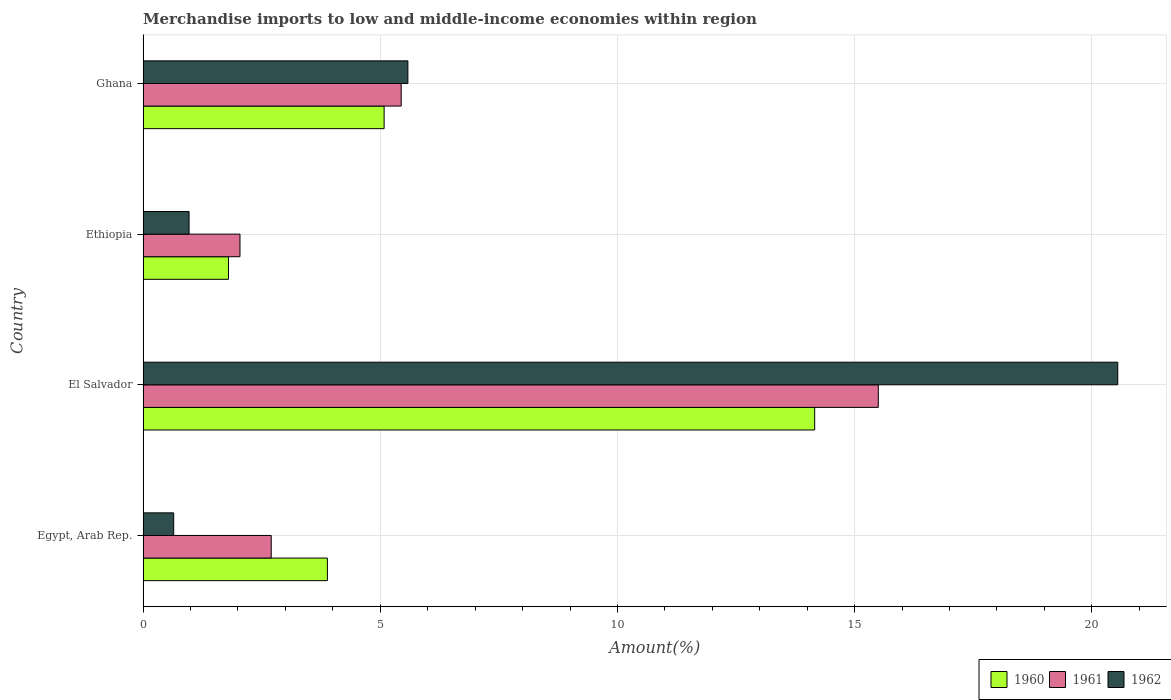How many groups of bars are there?
Offer a very short reply. 4. Are the number of bars per tick equal to the number of legend labels?
Your answer should be very brief. Yes. Are the number of bars on each tick of the Y-axis equal?
Your response must be concise. Yes. How many bars are there on the 4th tick from the top?
Your response must be concise. 3. In how many cases, is the number of bars for a given country not equal to the number of legend labels?
Provide a short and direct response. 0. What is the percentage of amount earned from merchandise imports in 1961 in Ghana?
Make the answer very short. 5.44. Across all countries, what is the maximum percentage of amount earned from merchandise imports in 1962?
Make the answer very short. 20.55. Across all countries, what is the minimum percentage of amount earned from merchandise imports in 1961?
Offer a terse response. 2.04. In which country was the percentage of amount earned from merchandise imports in 1960 maximum?
Your answer should be compact. El Salvador. In which country was the percentage of amount earned from merchandise imports in 1961 minimum?
Keep it short and to the point. Ethiopia. What is the total percentage of amount earned from merchandise imports in 1961 in the graph?
Ensure brevity in your answer.  25.68. What is the difference between the percentage of amount earned from merchandise imports in 1962 in Ethiopia and that in Ghana?
Provide a succinct answer. -4.61. What is the difference between the percentage of amount earned from merchandise imports in 1961 in Ghana and the percentage of amount earned from merchandise imports in 1960 in Egypt, Arab Rep.?
Offer a very short reply. 1.56. What is the average percentage of amount earned from merchandise imports in 1961 per country?
Give a very brief answer. 6.42. What is the difference between the percentage of amount earned from merchandise imports in 1962 and percentage of amount earned from merchandise imports in 1961 in Egypt, Arab Rep.?
Provide a short and direct response. -2.06. In how many countries, is the percentage of amount earned from merchandise imports in 1960 greater than 3 %?
Provide a short and direct response. 3. What is the ratio of the percentage of amount earned from merchandise imports in 1960 in El Salvador to that in Ethiopia?
Provide a short and direct response. 7.86. What is the difference between the highest and the second highest percentage of amount earned from merchandise imports in 1961?
Your answer should be very brief. 10.06. What is the difference between the highest and the lowest percentage of amount earned from merchandise imports in 1961?
Your response must be concise. 13.46. In how many countries, is the percentage of amount earned from merchandise imports in 1962 greater than the average percentage of amount earned from merchandise imports in 1962 taken over all countries?
Provide a short and direct response. 1. Is the sum of the percentage of amount earned from merchandise imports in 1962 in Egypt, Arab Rep. and Ghana greater than the maximum percentage of amount earned from merchandise imports in 1961 across all countries?
Your answer should be very brief. No. What does the 2nd bar from the top in El Salvador represents?
Keep it short and to the point. 1961. What does the 1st bar from the bottom in Ethiopia represents?
Make the answer very short. 1960. Is it the case that in every country, the sum of the percentage of amount earned from merchandise imports in 1960 and percentage of amount earned from merchandise imports in 1961 is greater than the percentage of amount earned from merchandise imports in 1962?
Offer a terse response. Yes. Are the values on the major ticks of X-axis written in scientific E-notation?
Provide a short and direct response. No. Does the graph contain any zero values?
Ensure brevity in your answer.  No. How are the legend labels stacked?
Ensure brevity in your answer.  Horizontal. What is the title of the graph?
Your response must be concise. Merchandise imports to low and middle-income economies within region. What is the label or title of the X-axis?
Give a very brief answer. Amount(%). What is the Amount(%) of 1960 in Egypt, Arab Rep.?
Give a very brief answer. 3.89. What is the Amount(%) of 1961 in Egypt, Arab Rep.?
Your response must be concise. 2.7. What is the Amount(%) in 1962 in Egypt, Arab Rep.?
Make the answer very short. 0.65. What is the Amount(%) of 1960 in El Salvador?
Keep it short and to the point. 14.16. What is the Amount(%) in 1961 in El Salvador?
Make the answer very short. 15.5. What is the Amount(%) of 1962 in El Salvador?
Keep it short and to the point. 20.55. What is the Amount(%) of 1960 in Ethiopia?
Keep it short and to the point. 1.8. What is the Amount(%) of 1961 in Ethiopia?
Give a very brief answer. 2.04. What is the Amount(%) of 1962 in Ethiopia?
Offer a terse response. 0.97. What is the Amount(%) in 1960 in Ghana?
Provide a succinct answer. 5.08. What is the Amount(%) in 1961 in Ghana?
Your answer should be very brief. 5.44. What is the Amount(%) of 1962 in Ghana?
Offer a terse response. 5.58. Across all countries, what is the maximum Amount(%) of 1960?
Give a very brief answer. 14.16. Across all countries, what is the maximum Amount(%) in 1961?
Offer a terse response. 15.5. Across all countries, what is the maximum Amount(%) in 1962?
Provide a succinct answer. 20.55. Across all countries, what is the minimum Amount(%) in 1960?
Provide a short and direct response. 1.8. Across all countries, what is the minimum Amount(%) in 1961?
Offer a very short reply. 2.04. Across all countries, what is the minimum Amount(%) of 1962?
Offer a terse response. 0.65. What is the total Amount(%) in 1960 in the graph?
Your answer should be compact. 24.92. What is the total Amount(%) of 1961 in the graph?
Ensure brevity in your answer.  25.68. What is the total Amount(%) in 1962 in the graph?
Your response must be concise. 27.74. What is the difference between the Amount(%) in 1960 in Egypt, Arab Rep. and that in El Salvador?
Ensure brevity in your answer.  -10.27. What is the difference between the Amount(%) of 1961 in Egypt, Arab Rep. and that in El Salvador?
Your answer should be very brief. -12.8. What is the difference between the Amount(%) of 1962 in Egypt, Arab Rep. and that in El Salvador?
Offer a terse response. -19.9. What is the difference between the Amount(%) of 1960 in Egypt, Arab Rep. and that in Ethiopia?
Provide a succinct answer. 2.08. What is the difference between the Amount(%) in 1961 in Egypt, Arab Rep. and that in Ethiopia?
Your answer should be compact. 0.66. What is the difference between the Amount(%) of 1962 in Egypt, Arab Rep. and that in Ethiopia?
Your answer should be very brief. -0.32. What is the difference between the Amount(%) in 1960 in Egypt, Arab Rep. and that in Ghana?
Give a very brief answer. -1.2. What is the difference between the Amount(%) in 1961 in Egypt, Arab Rep. and that in Ghana?
Your answer should be compact. -2.74. What is the difference between the Amount(%) in 1962 in Egypt, Arab Rep. and that in Ghana?
Make the answer very short. -4.94. What is the difference between the Amount(%) of 1960 in El Salvador and that in Ethiopia?
Provide a short and direct response. 12.36. What is the difference between the Amount(%) of 1961 in El Salvador and that in Ethiopia?
Provide a succinct answer. 13.46. What is the difference between the Amount(%) of 1962 in El Salvador and that in Ethiopia?
Provide a short and direct response. 19.58. What is the difference between the Amount(%) in 1960 in El Salvador and that in Ghana?
Your answer should be compact. 9.08. What is the difference between the Amount(%) in 1961 in El Salvador and that in Ghana?
Offer a very short reply. 10.06. What is the difference between the Amount(%) of 1962 in El Salvador and that in Ghana?
Your answer should be very brief. 14.96. What is the difference between the Amount(%) in 1960 in Ethiopia and that in Ghana?
Offer a terse response. -3.28. What is the difference between the Amount(%) of 1961 in Ethiopia and that in Ghana?
Offer a terse response. -3.4. What is the difference between the Amount(%) of 1962 in Ethiopia and that in Ghana?
Your answer should be very brief. -4.61. What is the difference between the Amount(%) of 1960 in Egypt, Arab Rep. and the Amount(%) of 1961 in El Salvador?
Give a very brief answer. -11.61. What is the difference between the Amount(%) of 1960 in Egypt, Arab Rep. and the Amount(%) of 1962 in El Salvador?
Provide a short and direct response. -16.66. What is the difference between the Amount(%) in 1961 in Egypt, Arab Rep. and the Amount(%) in 1962 in El Salvador?
Your answer should be very brief. -17.84. What is the difference between the Amount(%) in 1960 in Egypt, Arab Rep. and the Amount(%) in 1961 in Ethiopia?
Offer a terse response. 1.84. What is the difference between the Amount(%) of 1960 in Egypt, Arab Rep. and the Amount(%) of 1962 in Ethiopia?
Give a very brief answer. 2.92. What is the difference between the Amount(%) in 1961 in Egypt, Arab Rep. and the Amount(%) in 1962 in Ethiopia?
Your answer should be compact. 1.73. What is the difference between the Amount(%) in 1960 in Egypt, Arab Rep. and the Amount(%) in 1961 in Ghana?
Offer a very short reply. -1.56. What is the difference between the Amount(%) of 1960 in Egypt, Arab Rep. and the Amount(%) of 1962 in Ghana?
Your response must be concise. -1.7. What is the difference between the Amount(%) in 1961 in Egypt, Arab Rep. and the Amount(%) in 1962 in Ghana?
Make the answer very short. -2.88. What is the difference between the Amount(%) in 1960 in El Salvador and the Amount(%) in 1961 in Ethiopia?
Ensure brevity in your answer.  12.11. What is the difference between the Amount(%) in 1960 in El Salvador and the Amount(%) in 1962 in Ethiopia?
Provide a short and direct response. 13.19. What is the difference between the Amount(%) of 1961 in El Salvador and the Amount(%) of 1962 in Ethiopia?
Your response must be concise. 14.53. What is the difference between the Amount(%) in 1960 in El Salvador and the Amount(%) in 1961 in Ghana?
Your answer should be very brief. 8.72. What is the difference between the Amount(%) in 1960 in El Salvador and the Amount(%) in 1962 in Ghana?
Make the answer very short. 8.57. What is the difference between the Amount(%) of 1961 in El Salvador and the Amount(%) of 1962 in Ghana?
Give a very brief answer. 9.92. What is the difference between the Amount(%) in 1960 in Ethiopia and the Amount(%) in 1961 in Ghana?
Offer a very short reply. -3.64. What is the difference between the Amount(%) in 1960 in Ethiopia and the Amount(%) in 1962 in Ghana?
Offer a terse response. -3.78. What is the difference between the Amount(%) in 1961 in Ethiopia and the Amount(%) in 1962 in Ghana?
Make the answer very short. -3.54. What is the average Amount(%) in 1960 per country?
Your answer should be compact. 6.23. What is the average Amount(%) in 1961 per country?
Keep it short and to the point. 6.42. What is the average Amount(%) in 1962 per country?
Ensure brevity in your answer.  6.94. What is the difference between the Amount(%) of 1960 and Amount(%) of 1961 in Egypt, Arab Rep.?
Offer a very short reply. 1.18. What is the difference between the Amount(%) in 1960 and Amount(%) in 1962 in Egypt, Arab Rep.?
Make the answer very short. 3.24. What is the difference between the Amount(%) of 1961 and Amount(%) of 1962 in Egypt, Arab Rep.?
Your response must be concise. 2.06. What is the difference between the Amount(%) in 1960 and Amount(%) in 1961 in El Salvador?
Your response must be concise. -1.34. What is the difference between the Amount(%) of 1960 and Amount(%) of 1962 in El Salvador?
Give a very brief answer. -6.39. What is the difference between the Amount(%) of 1961 and Amount(%) of 1962 in El Salvador?
Provide a short and direct response. -5.05. What is the difference between the Amount(%) of 1960 and Amount(%) of 1961 in Ethiopia?
Offer a terse response. -0.24. What is the difference between the Amount(%) in 1960 and Amount(%) in 1962 in Ethiopia?
Offer a very short reply. 0.83. What is the difference between the Amount(%) in 1961 and Amount(%) in 1962 in Ethiopia?
Keep it short and to the point. 1.07. What is the difference between the Amount(%) of 1960 and Amount(%) of 1961 in Ghana?
Your answer should be very brief. -0.36. What is the difference between the Amount(%) in 1960 and Amount(%) in 1962 in Ghana?
Make the answer very short. -0.5. What is the difference between the Amount(%) in 1961 and Amount(%) in 1962 in Ghana?
Your response must be concise. -0.14. What is the ratio of the Amount(%) in 1960 in Egypt, Arab Rep. to that in El Salvador?
Provide a succinct answer. 0.27. What is the ratio of the Amount(%) in 1961 in Egypt, Arab Rep. to that in El Salvador?
Offer a very short reply. 0.17. What is the ratio of the Amount(%) in 1962 in Egypt, Arab Rep. to that in El Salvador?
Your answer should be very brief. 0.03. What is the ratio of the Amount(%) of 1960 in Egypt, Arab Rep. to that in Ethiopia?
Make the answer very short. 2.16. What is the ratio of the Amount(%) of 1961 in Egypt, Arab Rep. to that in Ethiopia?
Offer a very short reply. 1.32. What is the ratio of the Amount(%) in 1962 in Egypt, Arab Rep. to that in Ethiopia?
Provide a succinct answer. 0.67. What is the ratio of the Amount(%) of 1960 in Egypt, Arab Rep. to that in Ghana?
Your answer should be compact. 0.76. What is the ratio of the Amount(%) in 1961 in Egypt, Arab Rep. to that in Ghana?
Offer a very short reply. 0.5. What is the ratio of the Amount(%) in 1962 in Egypt, Arab Rep. to that in Ghana?
Provide a short and direct response. 0.12. What is the ratio of the Amount(%) in 1960 in El Salvador to that in Ethiopia?
Provide a succinct answer. 7.86. What is the ratio of the Amount(%) of 1961 in El Salvador to that in Ethiopia?
Ensure brevity in your answer.  7.59. What is the ratio of the Amount(%) in 1962 in El Salvador to that in Ethiopia?
Offer a terse response. 21.18. What is the ratio of the Amount(%) of 1960 in El Salvador to that in Ghana?
Keep it short and to the point. 2.79. What is the ratio of the Amount(%) of 1961 in El Salvador to that in Ghana?
Keep it short and to the point. 2.85. What is the ratio of the Amount(%) of 1962 in El Salvador to that in Ghana?
Your answer should be compact. 3.68. What is the ratio of the Amount(%) of 1960 in Ethiopia to that in Ghana?
Your response must be concise. 0.35. What is the ratio of the Amount(%) in 1961 in Ethiopia to that in Ghana?
Offer a very short reply. 0.38. What is the ratio of the Amount(%) in 1962 in Ethiopia to that in Ghana?
Provide a succinct answer. 0.17. What is the difference between the highest and the second highest Amount(%) in 1960?
Keep it short and to the point. 9.08. What is the difference between the highest and the second highest Amount(%) of 1961?
Offer a very short reply. 10.06. What is the difference between the highest and the second highest Amount(%) of 1962?
Give a very brief answer. 14.96. What is the difference between the highest and the lowest Amount(%) in 1960?
Your answer should be compact. 12.36. What is the difference between the highest and the lowest Amount(%) in 1961?
Your answer should be compact. 13.46. What is the difference between the highest and the lowest Amount(%) of 1962?
Your answer should be compact. 19.9. 